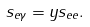<formula> <loc_0><loc_0><loc_500><loc_500>s _ { e \gamma } = y s _ { e e } .</formula> 